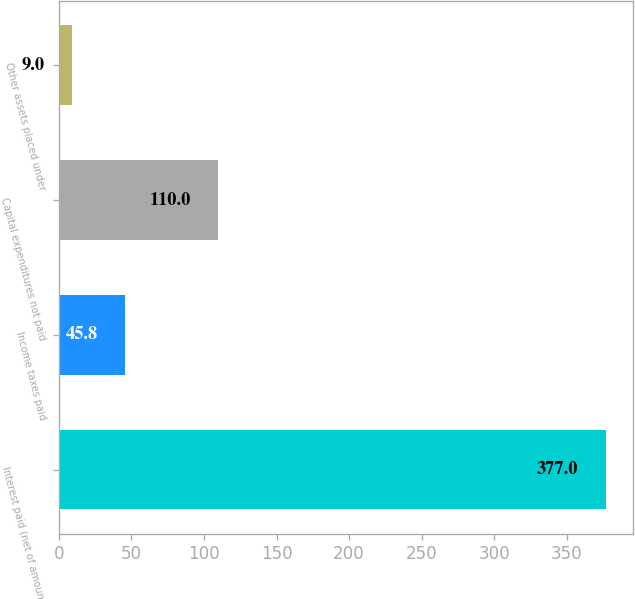Convert chart to OTSL. <chart><loc_0><loc_0><loc_500><loc_500><bar_chart><fcel>Interest paid (net of amounts<fcel>Income taxes paid<fcel>Capital expenditures not paid<fcel>Other assets placed under<nl><fcel>377<fcel>45.8<fcel>110<fcel>9<nl></chart> 